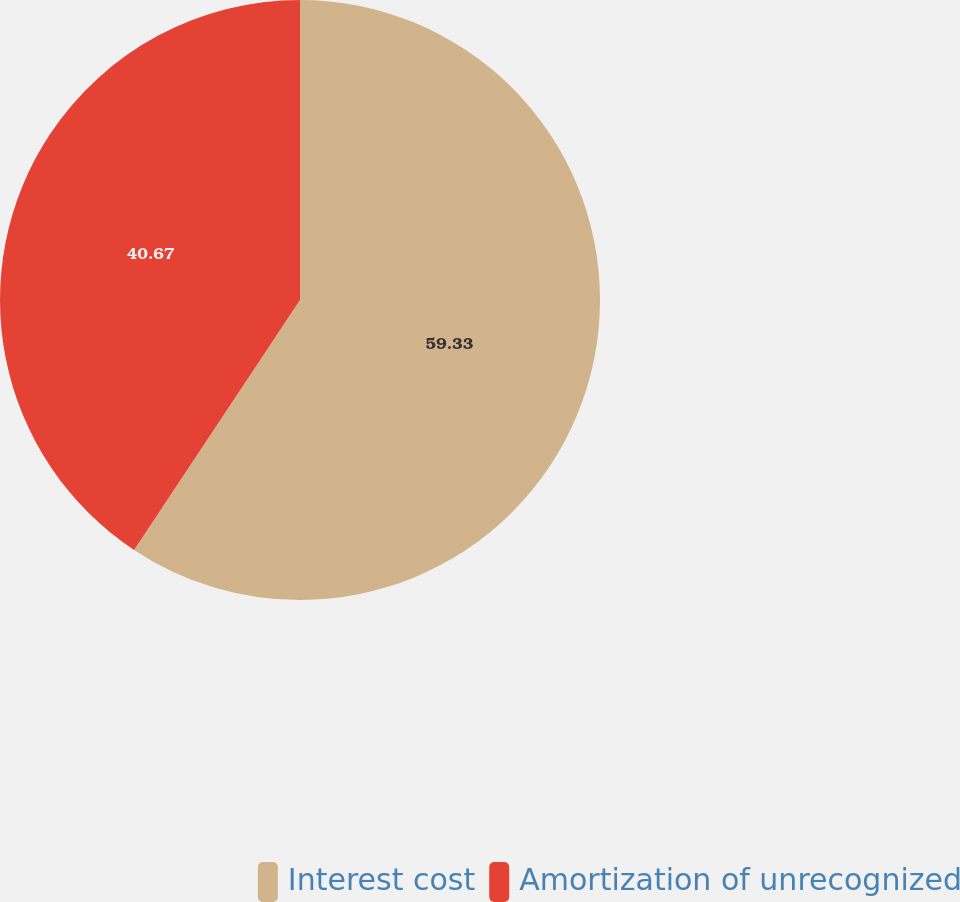Convert chart. <chart><loc_0><loc_0><loc_500><loc_500><pie_chart><fcel>Interest cost<fcel>Amortization of unrecognized<nl><fcel>59.33%<fcel>40.67%<nl></chart> 